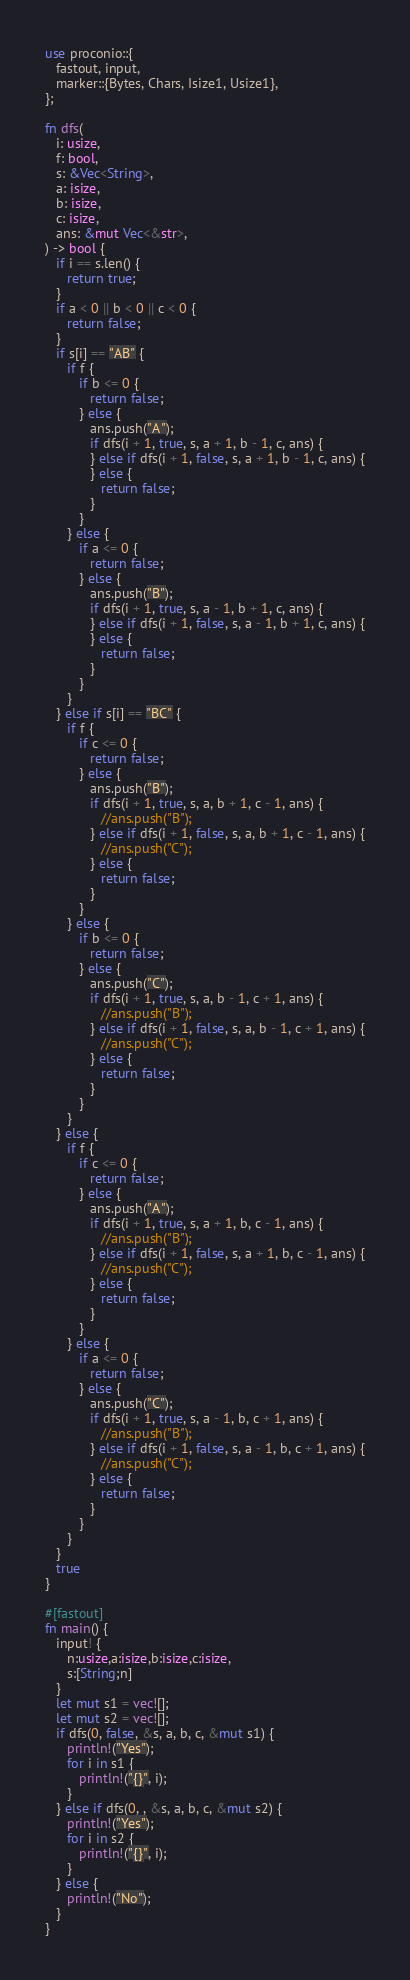Convert code to text. <code><loc_0><loc_0><loc_500><loc_500><_Rust_>use proconio::{
   fastout, input,
   marker::{Bytes, Chars, Isize1, Usize1},
};

fn dfs(
   i: usize,
   f: bool,
   s: &Vec<String>,
   a: isize,
   b: isize,
   c: isize,
   ans: &mut Vec<&str>,
) -> bool {
   if i == s.len() {
      return true;
   }
   if a < 0 || b < 0 || c < 0 {
      return false;
   }
   if s[i] == "AB" {
      if f {
         if b <= 0 {
            return false;
         } else {
            ans.push("A");
            if dfs(i + 1, true, s, a + 1, b - 1, c, ans) {
            } else if dfs(i + 1, false, s, a + 1, b - 1, c, ans) {
            } else {
               return false;
            }
         }
      } else {
         if a <= 0 {
            return false;
         } else {
            ans.push("B");
            if dfs(i + 1, true, s, a - 1, b + 1, c, ans) {
            } else if dfs(i + 1, false, s, a - 1, b + 1, c, ans) {
            } else {
               return false;
            }
         }
      }
   } else if s[i] == "BC" {
      if f {
         if c <= 0 {
            return false;
         } else {
            ans.push("B");
            if dfs(i + 1, true, s, a, b + 1, c - 1, ans) {
               //ans.push("B");
            } else if dfs(i + 1, false, s, a, b + 1, c - 1, ans) {
               //ans.push("C");
            } else {
               return false;
            }
         }
      } else {
         if b <= 0 {
            return false;
         } else {
            ans.push("C");
            if dfs(i + 1, true, s, a, b - 1, c + 1, ans) {
               //ans.push("B");
            } else if dfs(i + 1, false, s, a, b - 1, c + 1, ans) {
               //ans.push("C");
            } else {
               return false;
            }
         }
      }
   } else {
      if f {
         if c <= 0 {
            return false;
         } else {
            ans.push("A");
            if dfs(i + 1, true, s, a + 1, b, c - 1, ans) {
               //ans.push("B");
            } else if dfs(i + 1, false, s, a + 1, b, c - 1, ans) {
               //ans.push("C");
            } else {
               return false;
            }
         }
      } else {
         if a <= 0 {
            return false;
         } else {
            ans.push("C");
            if dfs(i + 1, true, s, a - 1, b, c + 1, ans) {
               //ans.push("B");
            } else if dfs(i + 1, false, s, a - 1, b, c + 1, ans) {
               //ans.push("C");
            } else {
               return false;
            }
         }
      }
   }
   true
}

#[fastout]
fn main() {
   input! {
      n:usize,a:isize,b:isize,c:isize,
      s:[String;n]
   }
   let mut s1 = vec![];
   let mut s2 = vec![];
   if dfs(0, false, &s, a, b, c, &mut s1) {
      println!("Yes");
      for i in s1 {
         println!("{}", i);
      }
   } else if dfs(0, , &s, a, b, c, &mut s2) {
      println!("Yes");
      for i in s2 {
         println!("{}", i);
      }
   } else {
      println!("No");
   }
}
</code> 